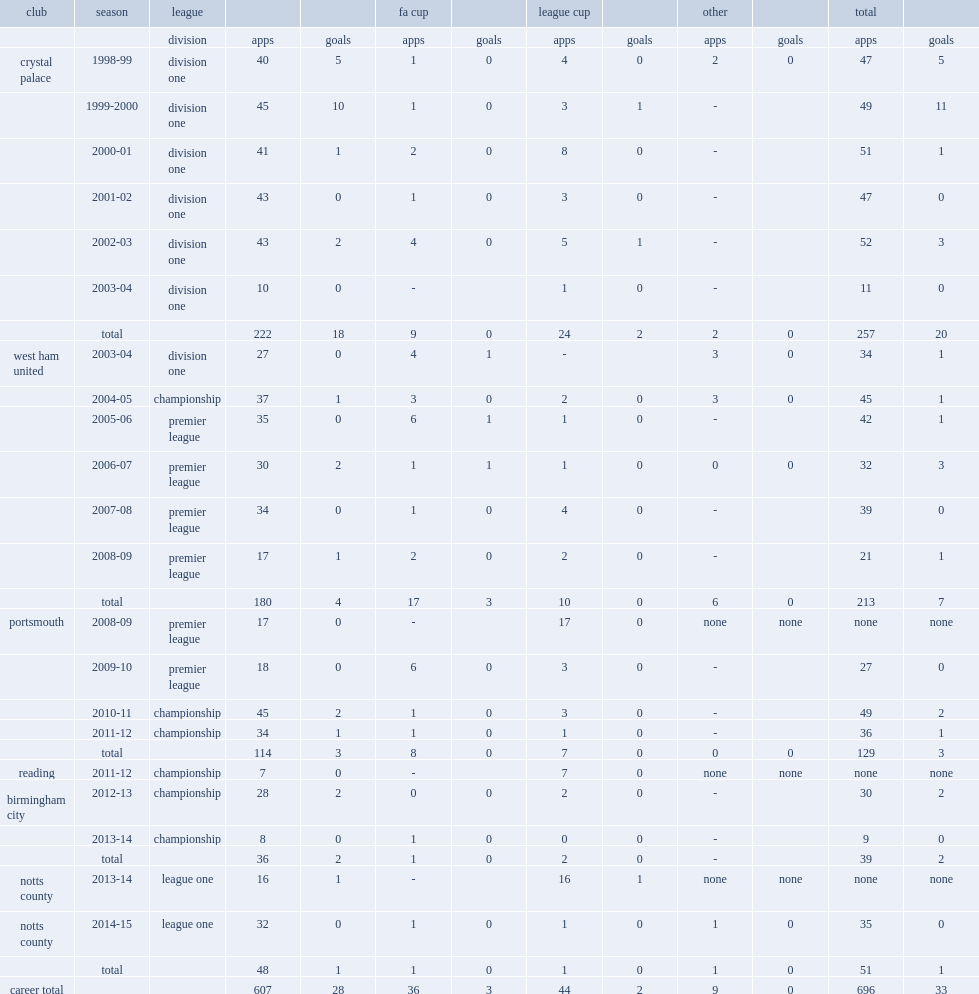How many league and cup appearances did hayden mullins make for the palace? 52.0. 